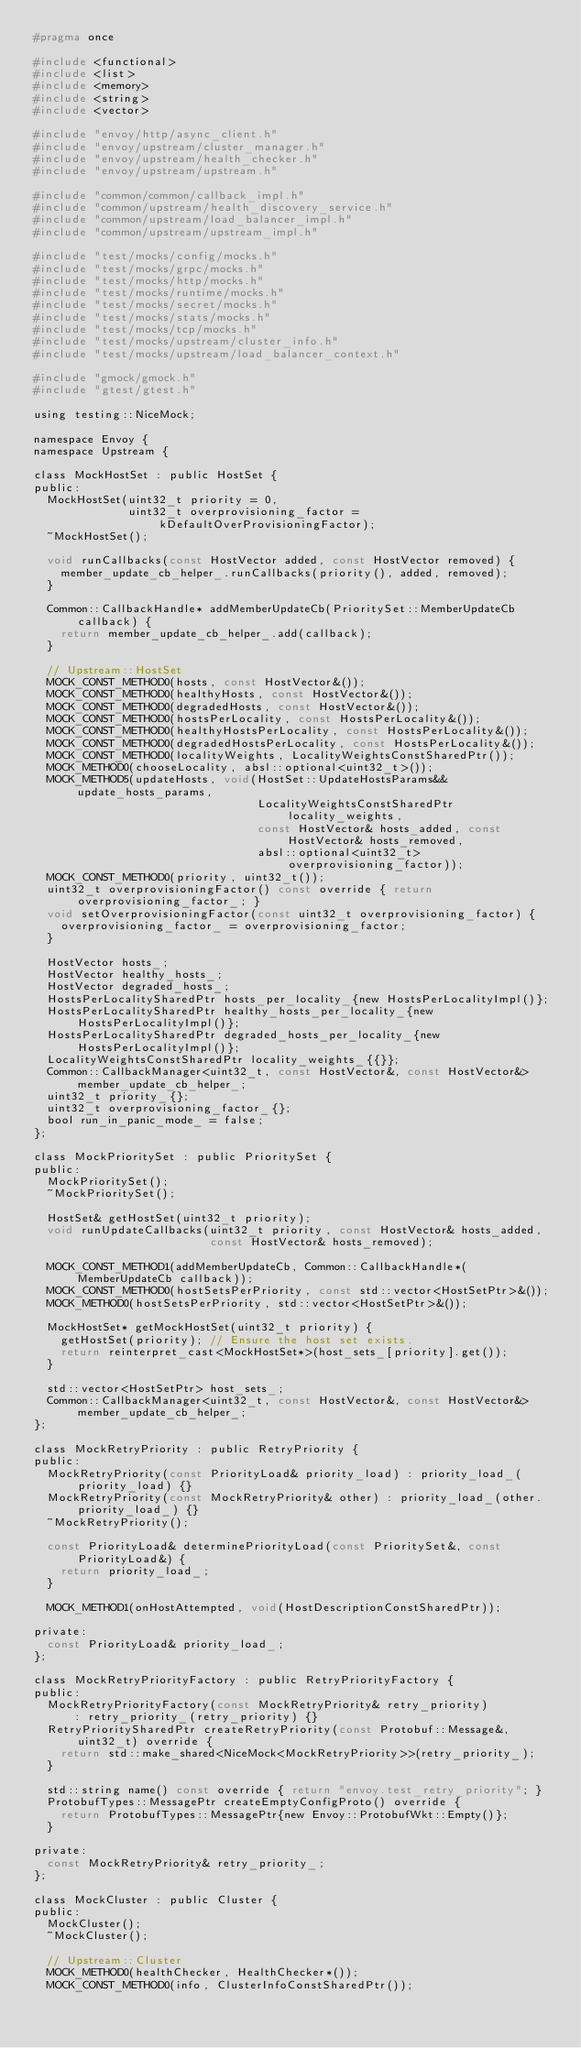<code> <loc_0><loc_0><loc_500><loc_500><_C_>#pragma once

#include <functional>
#include <list>
#include <memory>
#include <string>
#include <vector>

#include "envoy/http/async_client.h"
#include "envoy/upstream/cluster_manager.h"
#include "envoy/upstream/health_checker.h"
#include "envoy/upstream/upstream.h"

#include "common/common/callback_impl.h"
#include "common/upstream/health_discovery_service.h"
#include "common/upstream/load_balancer_impl.h"
#include "common/upstream/upstream_impl.h"

#include "test/mocks/config/mocks.h"
#include "test/mocks/grpc/mocks.h"
#include "test/mocks/http/mocks.h"
#include "test/mocks/runtime/mocks.h"
#include "test/mocks/secret/mocks.h"
#include "test/mocks/stats/mocks.h"
#include "test/mocks/tcp/mocks.h"
#include "test/mocks/upstream/cluster_info.h"
#include "test/mocks/upstream/load_balancer_context.h"

#include "gmock/gmock.h"
#include "gtest/gtest.h"

using testing::NiceMock;

namespace Envoy {
namespace Upstream {

class MockHostSet : public HostSet {
public:
  MockHostSet(uint32_t priority = 0,
              uint32_t overprovisioning_factor = kDefaultOverProvisioningFactor);
  ~MockHostSet();

  void runCallbacks(const HostVector added, const HostVector removed) {
    member_update_cb_helper_.runCallbacks(priority(), added, removed);
  }

  Common::CallbackHandle* addMemberUpdateCb(PrioritySet::MemberUpdateCb callback) {
    return member_update_cb_helper_.add(callback);
  }

  // Upstream::HostSet
  MOCK_CONST_METHOD0(hosts, const HostVector&());
  MOCK_CONST_METHOD0(healthyHosts, const HostVector&());
  MOCK_CONST_METHOD0(degradedHosts, const HostVector&());
  MOCK_CONST_METHOD0(hostsPerLocality, const HostsPerLocality&());
  MOCK_CONST_METHOD0(healthyHostsPerLocality, const HostsPerLocality&());
  MOCK_CONST_METHOD0(degradedHostsPerLocality, const HostsPerLocality&());
  MOCK_CONST_METHOD0(localityWeights, LocalityWeightsConstSharedPtr());
  MOCK_METHOD0(chooseLocality, absl::optional<uint32_t>());
  MOCK_METHOD5(updateHosts, void(HostSet::UpdateHostsParams&& update_hosts_params,
                                 LocalityWeightsConstSharedPtr locality_weights,
                                 const HostVector& hosts_added, const HostVector& hosts_removed,
                                 absl::optional<uint32_t> overprovisioning_factor));
  MOCK_CONST_METHOD0(priority, uint32_t());
  uint32_t overprovisioningFactor() const override { return overprovisioning_factor_; }
  void setOverprovisioningFactor(const uint32_t overprovisioning_factor) {
    overprovisioning_factor_ = overprovisioning_factor;
  }

  HostVector hosts_;
  HostVector healthy_hosts_;
  HostVector degraded_hosts_;
  HostsPerLocalitySharedPtr hosts_per_locality_{new HostsPerLocalityImpl()};
  HostsPerLocalitySharedPtr healthy_hosts_per_locality_{new HostsPerLocalityImpl()};
  HostsPerLocalitySharedPtr degraded_hosts_per_locality_{new HostsPerLocalityImpl()};
  LocalityWeightsConstSharedPtr locality_weights_{{}};
  Common::CallbackManager<uint32_t, const HostVector&, const HostVector&> member_update_cb_helper_;
  uint32_t priority_{};
  uint32_t overprovisioning_factor_{};
  bool run_in_panic_mode_ = false;
};

class MockPrioritySet : public PrioritySet {
public:
  MockPrioritySet();
  ~MockPrioritySet();

  HostSet& getHostSet(uint32_t priority);
  void runUpdateCallbacks(uint32_t priority, const HostVector& hosts_added,
                          const HostVector& hosts_removed);

  MOCK_CONST_METHOD1(addMemberUpdateCb, Common::CallbackHandle*(MemberUpdateCb callback));
  MOCK_CONST_METHOD0(hostSetsPerPriority, const std::vector<HostSetPtr>&());
  MOCK_METHOD0(hostSetsPerPriority, std::vector<HostSetPtr>&());

  MockHostSet* getMockHostSet(uint32_t priority) {
    getHostSet(priority); // Ensure the host set exists.
    return reinterpret_cast<MockHostSet*>(host_sets_[priority].get());
  }

  std::vector<HostSetPtr> host_sets_;
  Common::CallbackManager<uint32_t, const HostVector&, const HostVector&> member_update_cb_helper_;
};

class MockRetryPriority : public RetryPriority {
public:
  MockRetryPriority(const PriorityLoad& priority_load) : priority_load_(priority_load) {}
  MockRetryPriority(const MockRetryPriority& other) : priority_load_(other.priority_load_) {}
  ~MockRetryPriority();

  const PriorityLoad& determinePriorityLoad(const PrioritySet&, const PriorityLoad&) {
    return priority_load_;
  }

  MOCK_METHOD1(onHostAttempted, void(HostDescriptionConstSharedPtr));

private:
  const PriorityLoad& priority_load_;
};

class MockRetryPriorityFactory : public RetryPriorityFactory {
public:
  MockRetryPriorityFactory(const MockRetryPriority& retry_priority)
      : retry_priority_(retry_priority) {}
  RetryPrioritySharedPtr createRetryPriority(const Protobuf::Message&, uint32_t) override {
    return std::make_shared<NiceMock<MockRetryPriority>>(retry_priority_);
  }

  std::string name() const override { return "envoy.test_retry_priority"; }
  ProtobufTypes::MessagePtr createEmptyConfigProto() override {
    return ProtobufTypes::MessagePtr{new Envoy::ProtobufWkt::Empty()};
  }

private:
  const MockRetryPriority& retry_priority_;
};

class MockCluster : public Cluster {
public:
  MockCluster();
  ~MockCluster();

  // Upstream::Cluster
  MOCK_METHOD0(healthChecker, HealthChecker*());
  MOCK_CONST_METHOD0(info, ClusterInfoConstSharedPtr());</code> 